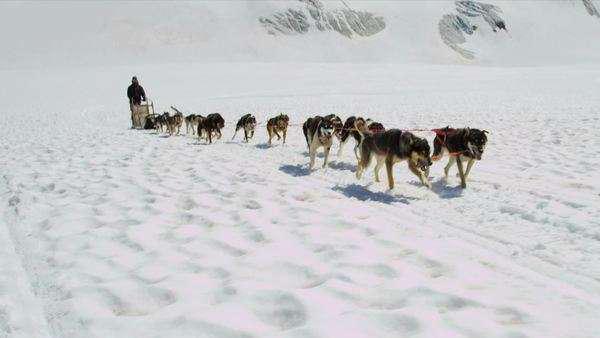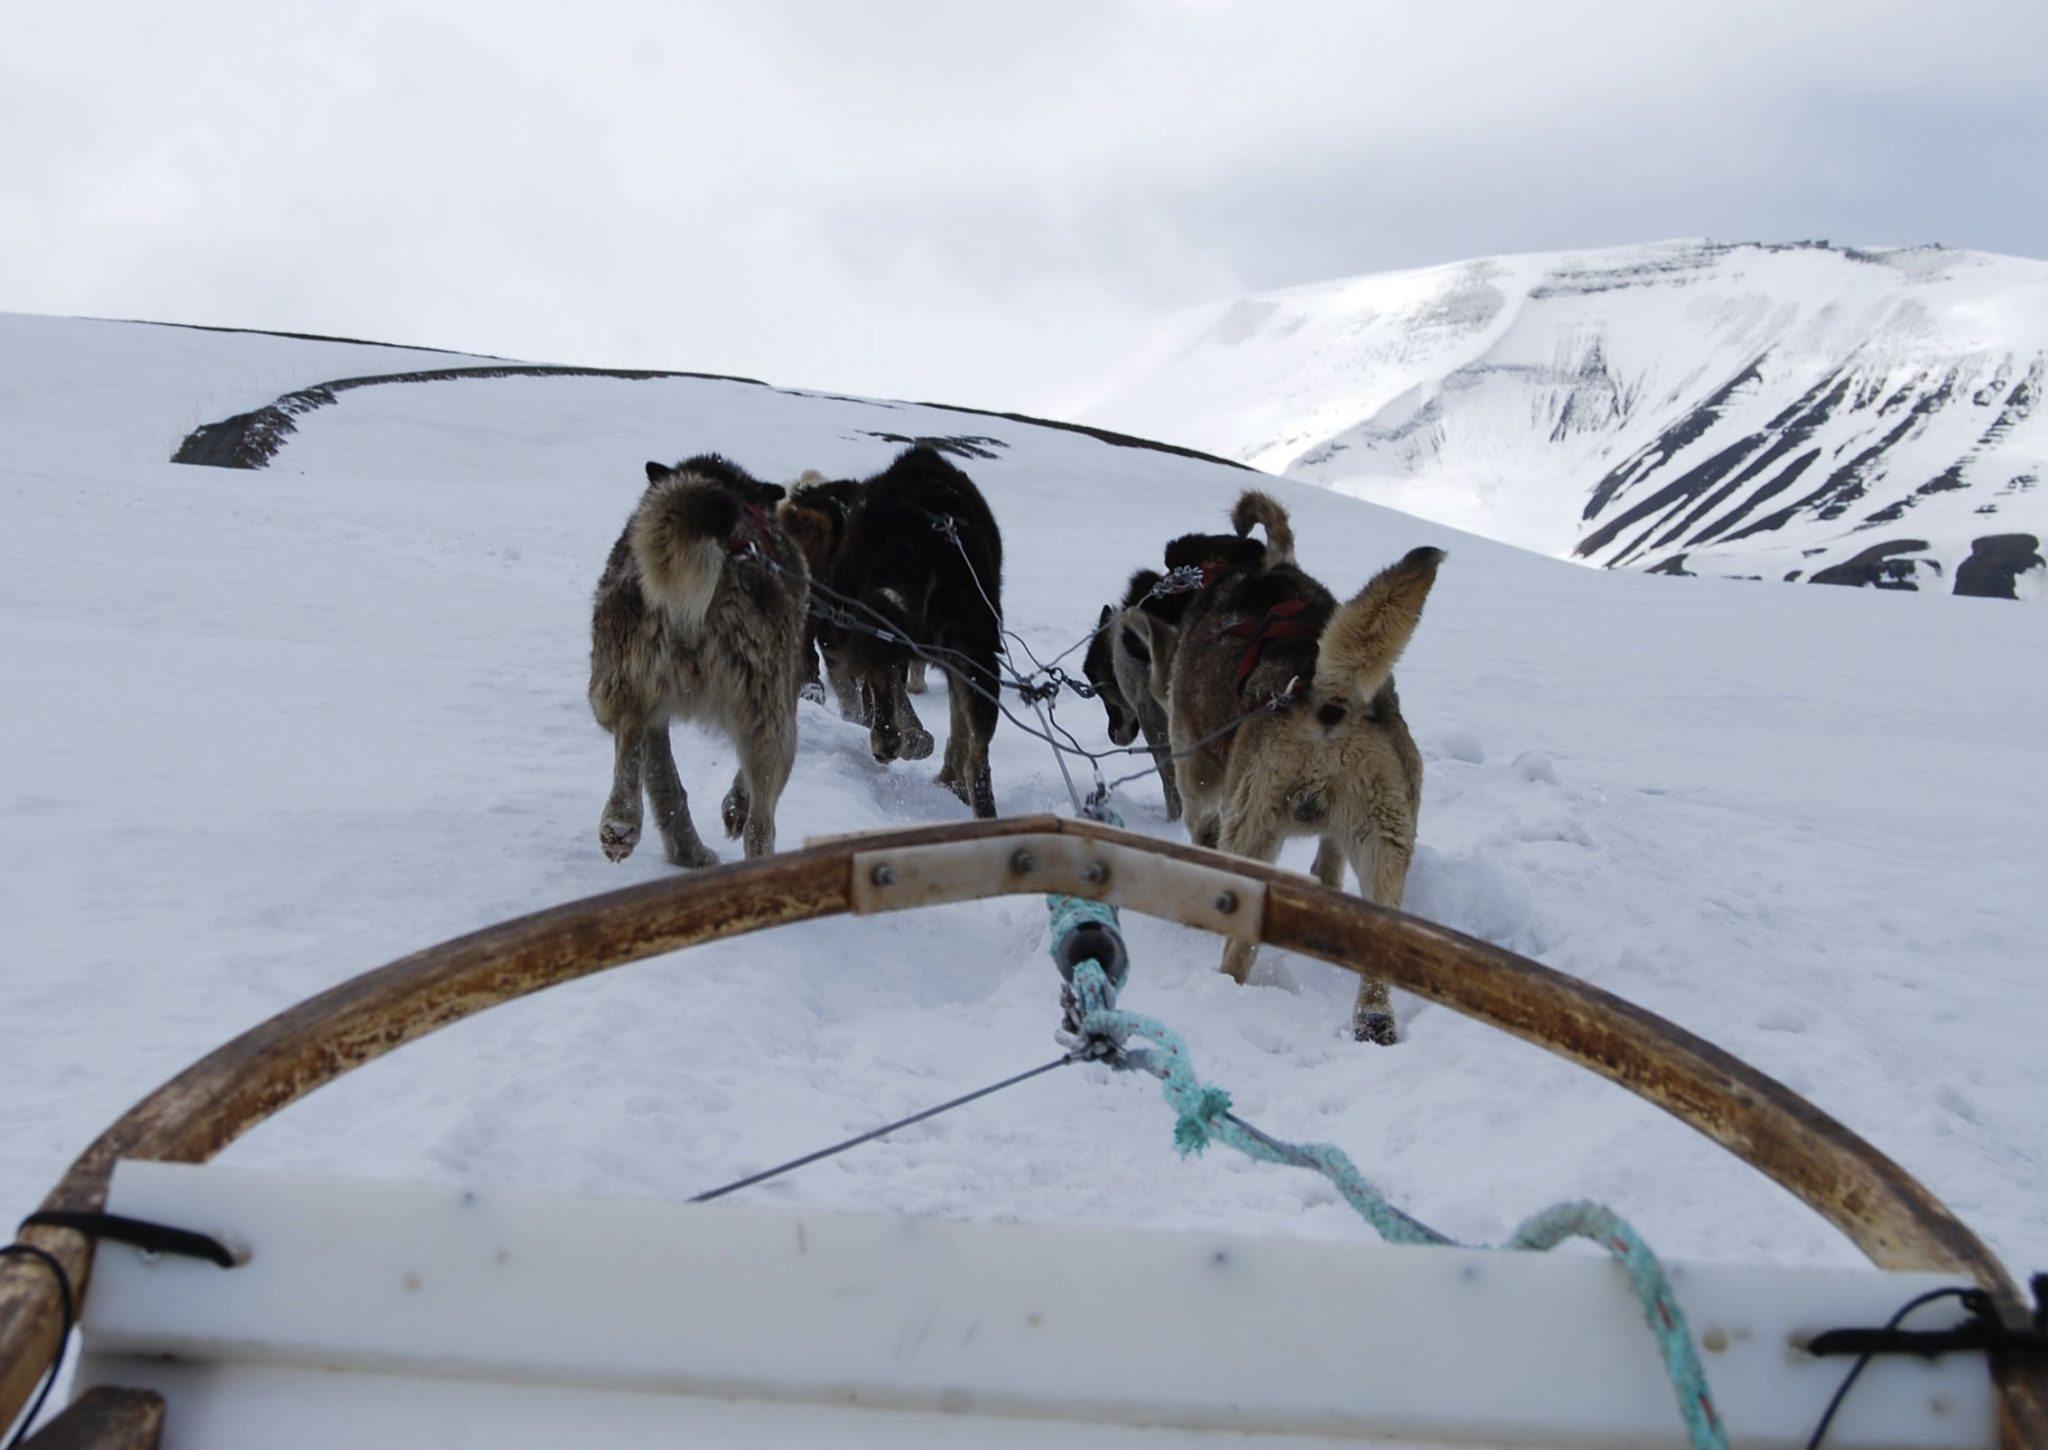The first image is the image on the left, the second image is the image on the right. Evaluate the accuracy of this statement regarding the images: "There are people in both images.". Is it true? Answer yes or no. No. 